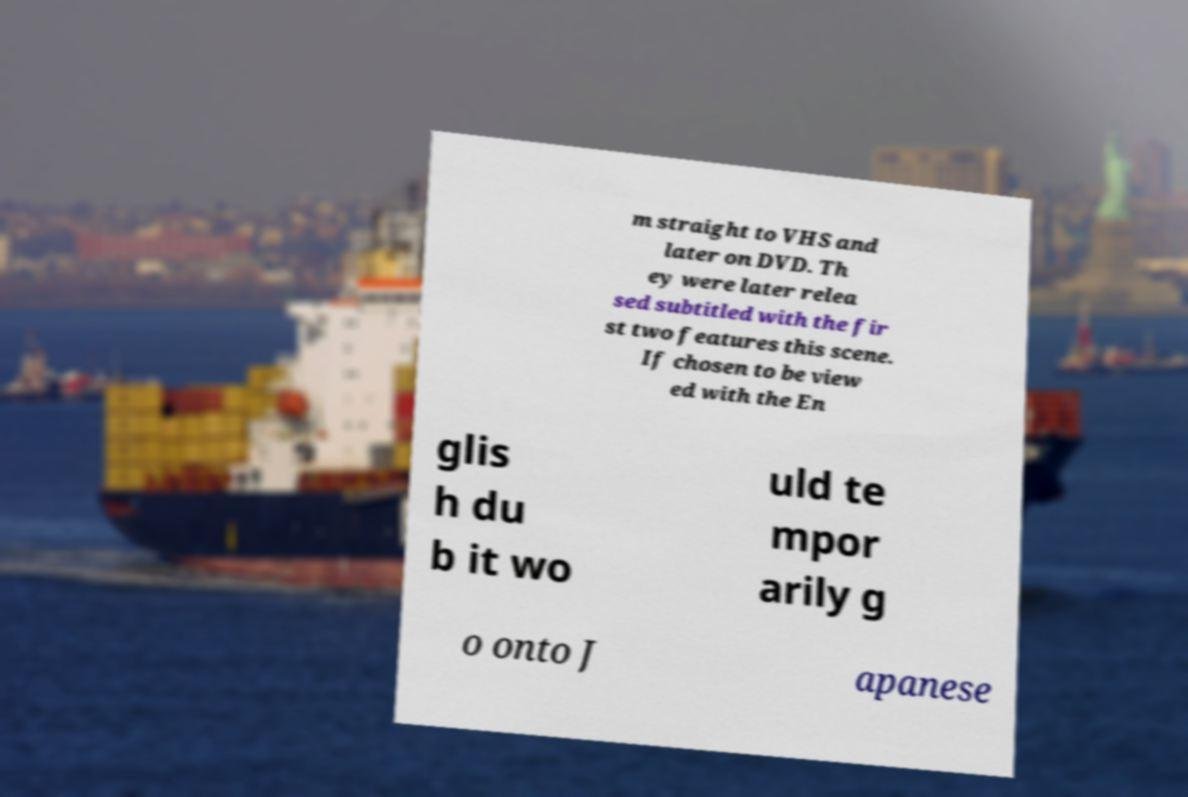Please identify and transcribe the text found in this image. m straight to VHS and later on DVD. Th ey were later relea sed subtitled with the fir st two features this scene. If chosen to be view ed with the En glis h du b it wo uld te mpor arily g o onto J apanese 